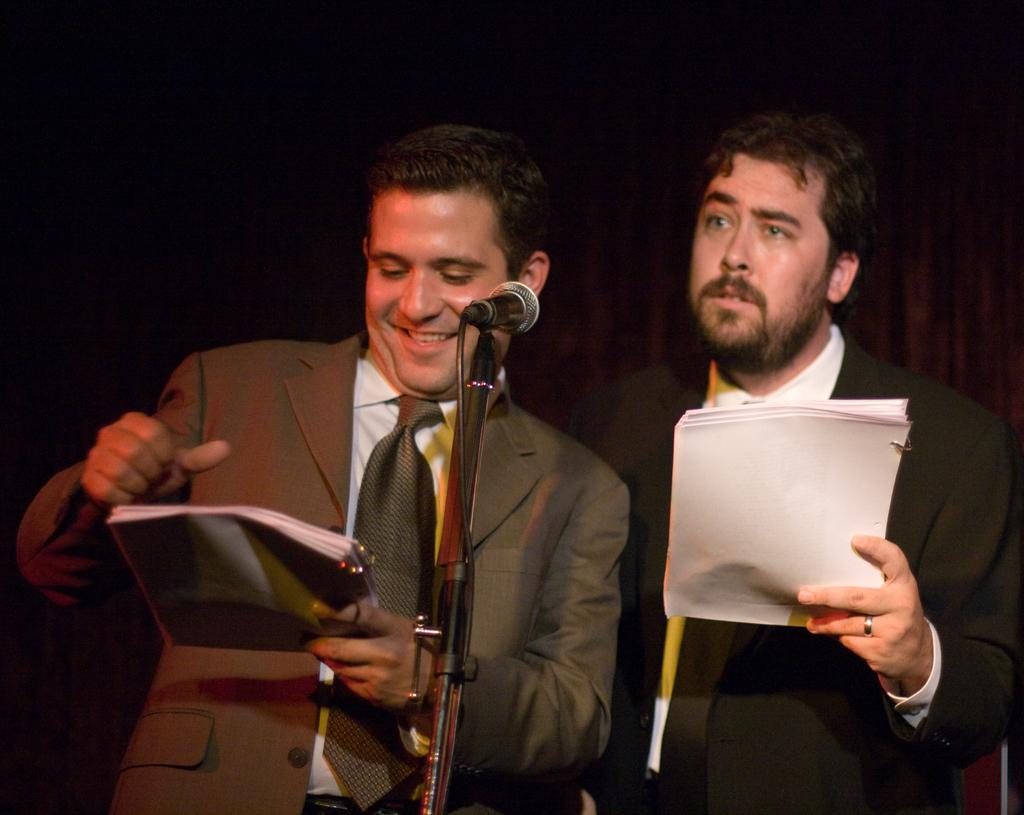How many people are in the image? There are two persons in the image. What are the persons wearing? The persons are wearing blazers. What are the persons holding in the image? The persons are holding papers. What object can be seen in the middle of the image? There is a microphone (mic) in the middle of the image. How many cherries are on the table in the image? There are no cherries present in the image. What station do the persons appear to be at in the image? The image does not provide any information about a station or location. 